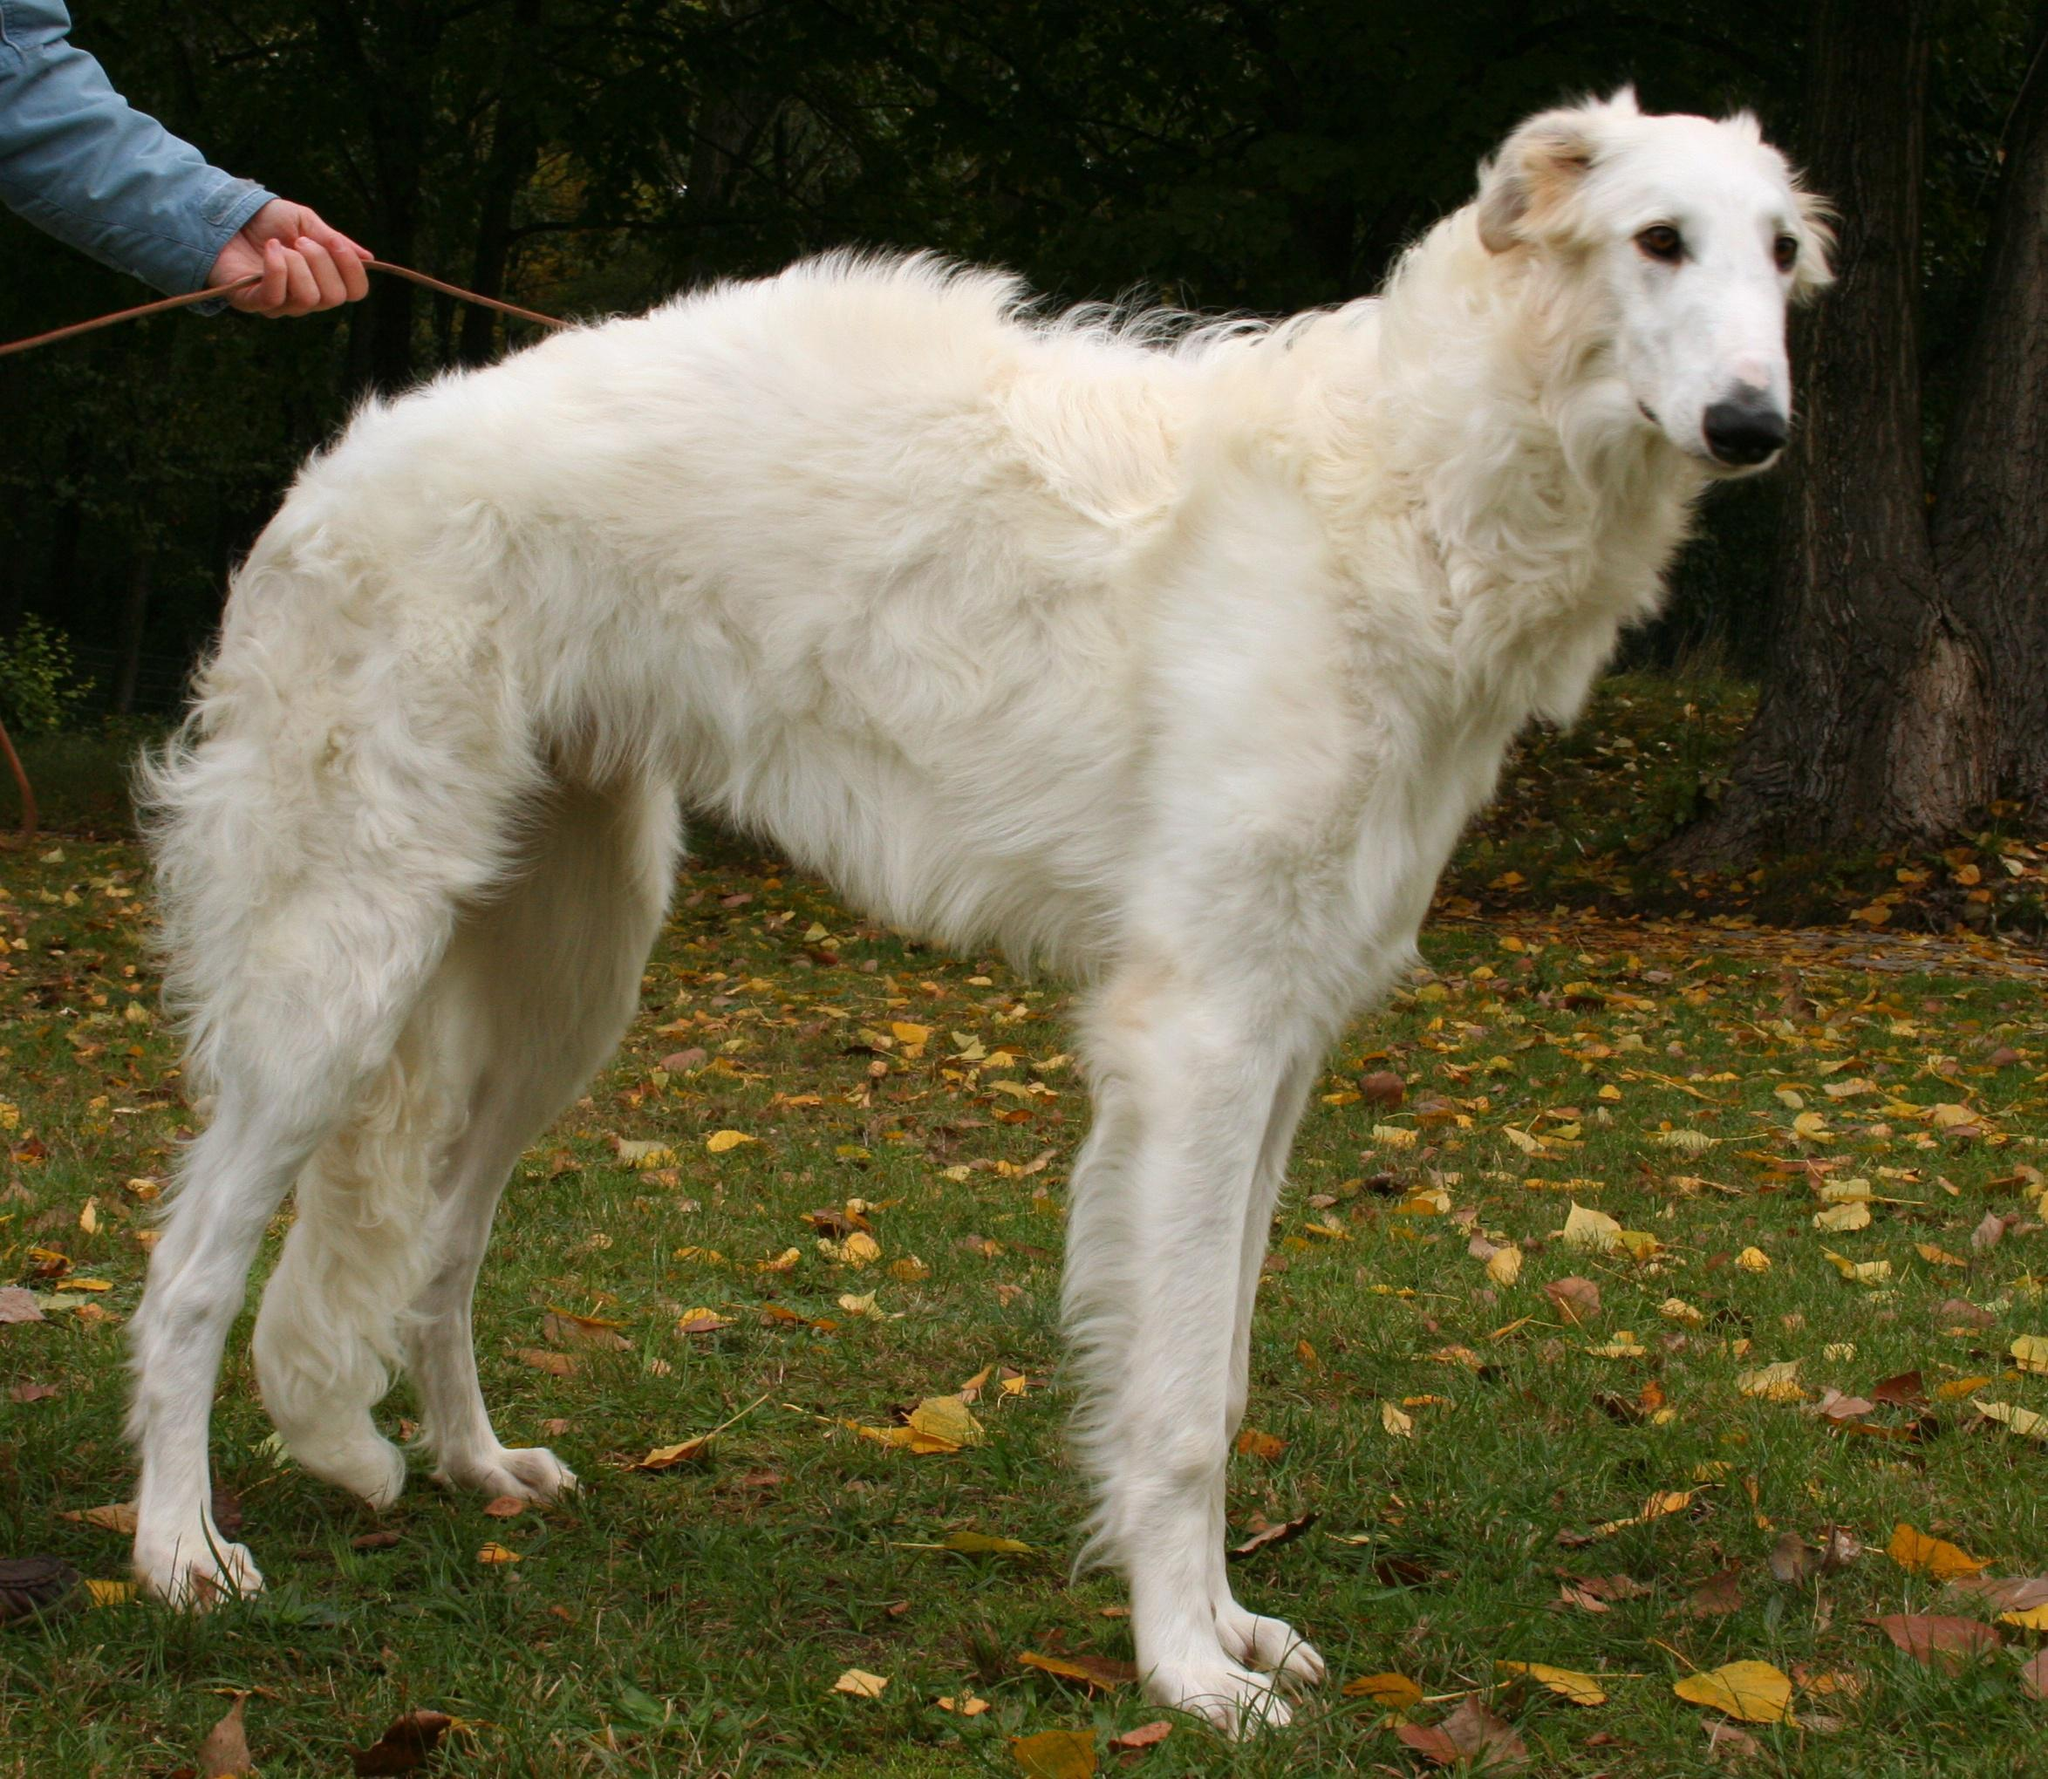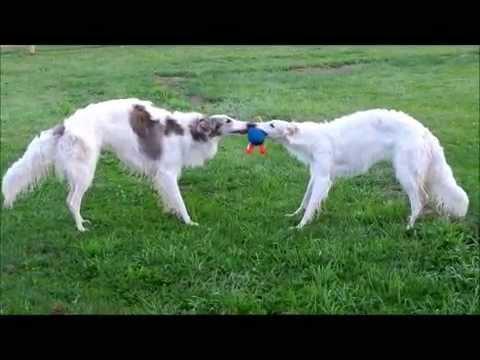The first image is the image on the left, the second image is the image on the right. Given the left and right images, does the statement "There are three hounds on the grass in total." hold true? Answer yes or no. Yes. 